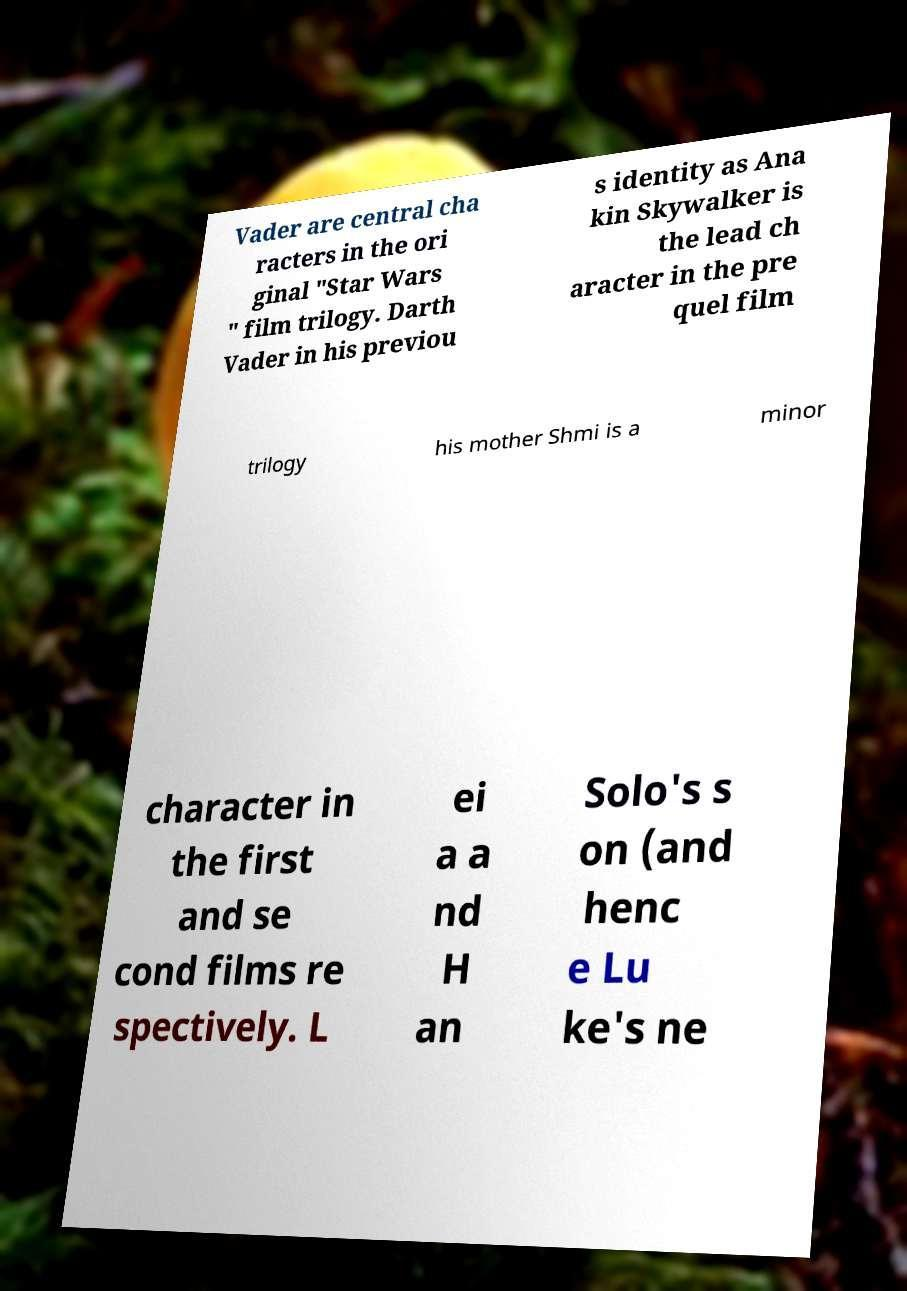Can you read and provide the text displayed in the image?This photo seems to have some interesting text. Can you extract and type it out for me? Vader are central cha racters in the ori ginal "Star Wars " film trilogy. Darth Vader in his previou s identity as Ana kin Skywalker is the lead ch aracter in the pre quel film trilogy his mother Shmi is a minor character in the first and se cond films re spectively. L ei a a nd H an Solo's s on (and henc e Lu ke's ne 